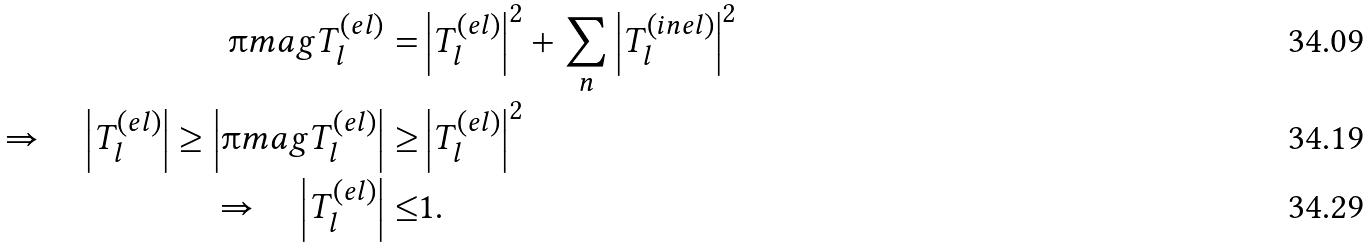Convert formula to latex. <formula><loc_0><loc_0><loc_500><loc_500>\i m a g T _ { l } ^ { ( e l ) } = & \left | T _ { l } ^ { ( e l ) } \right | ^ { 2 } + \sum _ { n } \left | T _ { l } ^ { ( i n e l ) } \right | ^ { 2 } \\ \Rightarrow \quad \left | T _ { l } ^ { ( e l ) } \right | \geq \left | \i m a g T _ { l } ^ { ( e l ) } \right | \geq & \left | T _ { l } ^ { ( e l ) } \right | ^ { 2 } \\ \Rightarrow \quad \left | T _ { l } ^ { ( e l ) } \right | \leq & 1 .</formula> 